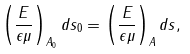<formula> <loc_0><loc_0><loc_500><loc_500>\left ( \frac { E } { \epsilon \mu } \right ) _ { A _ { 0 } } d s _ { 0 } = \left ( \frac { E } { \epsilon \mu } \right ) _ { A } d s ,</formula> 